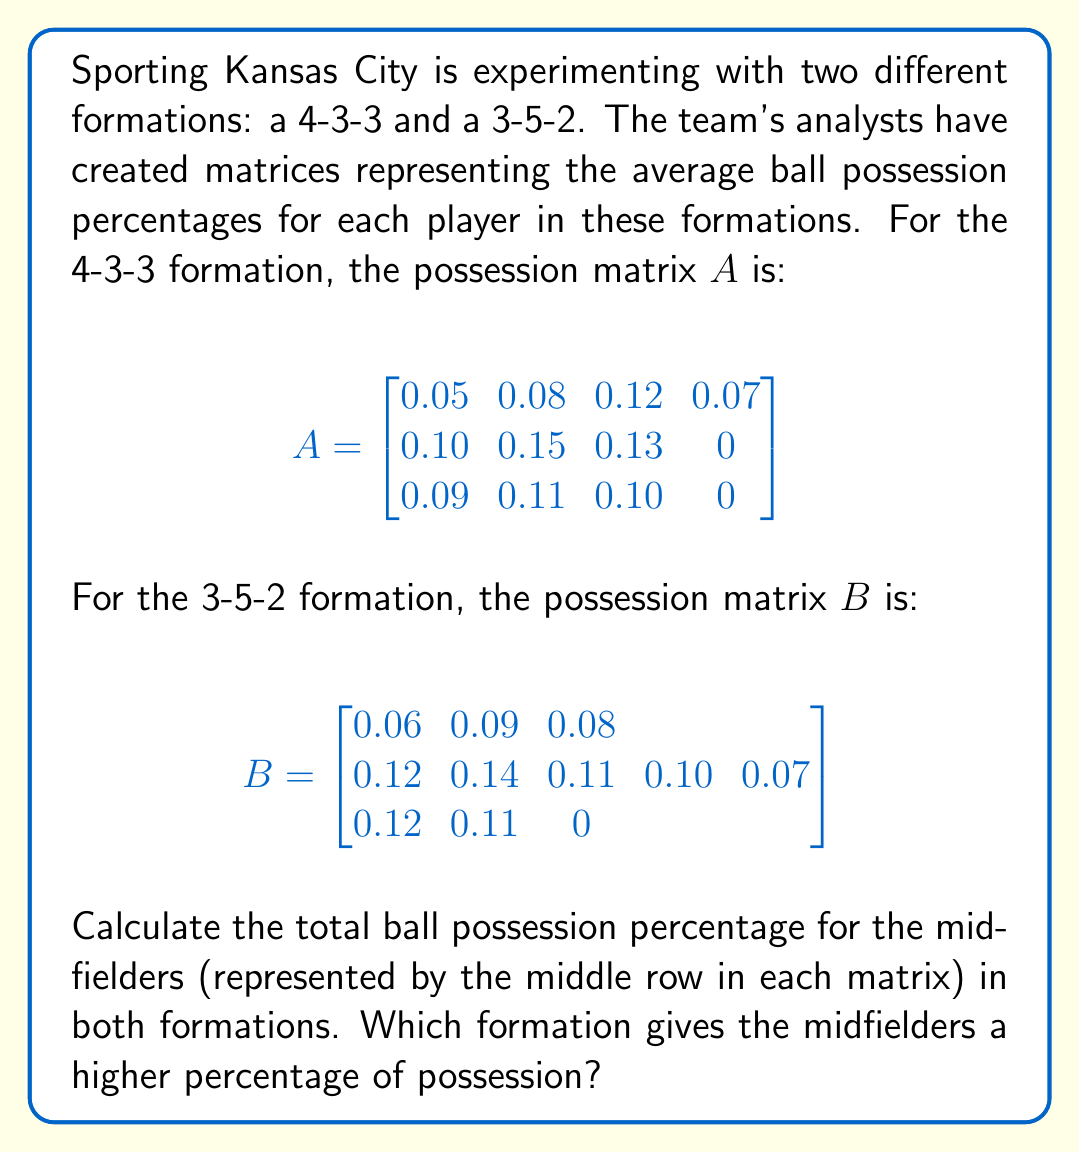Give your solution to this math problem. Let's approach this step-by-step:

1) For the 4-3-3 formation (matrix $A$):
   The midfielders are represented by the second row.
   Midfielder possession = $0.10 + 0.15 + 0.13 + 0 = 0.38$ or 38%

2) For the 3-5-2 formation (matrix $B$):
   The midfielders are represented by the second row.
   Midfielder possession = $0.12 + 0.14 + 0.11 + 0.10 + 0.07 = 0.54$ or 54%

3) Comparing the two results:
   4-3-3 formation: 38%
   3-5-2 formation: 54%

4) The 3-5-2 formation gives the midfielders a higher percentage of possession.

This analysis shows that the 3-5-2 formation allows the midfielders to have significantly more possession of the ball. This could potentially lead to better control of the game's tempo and more opportunities for creating scoring chances, which is certainly a silver lining for our optimistic Kansas City soccer fan!
Answer: 3-5-2 formation; 54% vs 38% 